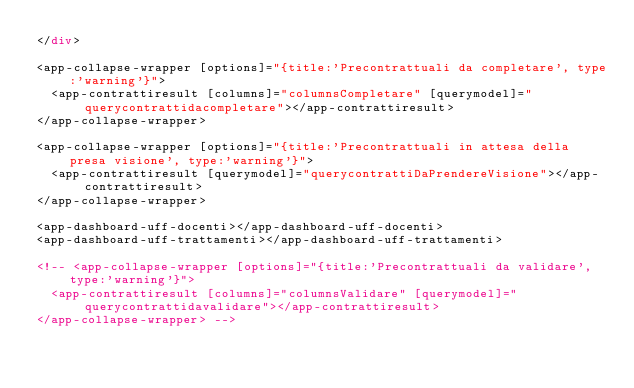<code> <loc_0><loc_0><loc_500><loc_500><_HTML_></div>

<app-collapse-wrapper [options]="{title:'Precontrattuali da completare', type:'warning'}">
  <app-contrattiresult [columns]="columnsCompletare" [querymodel]="querycontrattidacompletare"></app-contrattiresult>
</app-collapse-wrapper>

<app-collapse-wrapper [options]="{title:'Precontrattuali in attesa della presa visione', type:'warning'}">
  <app-contrattiresult [querymodel]="querycontrattiDaPrendereVisione"></app-contrattiresult>
</app-collapse-wrapper>

<app-dashboard-uff-docenti></app-dashboard-uff-docenti>
<app-dashboard-uff-trattamenti></app-dashboard-uff-trattamenti>

<!-- <app-collapse-wrapper [options]="{title:'Precontrattuali da validare', type:'warning'}">
  <app-contrattiresult [columns]="columnsValidare" [querymodel]="querycontrattidavalidare"></app-contrattiresult>
</app-collapse-wrapper> -->
</code> 